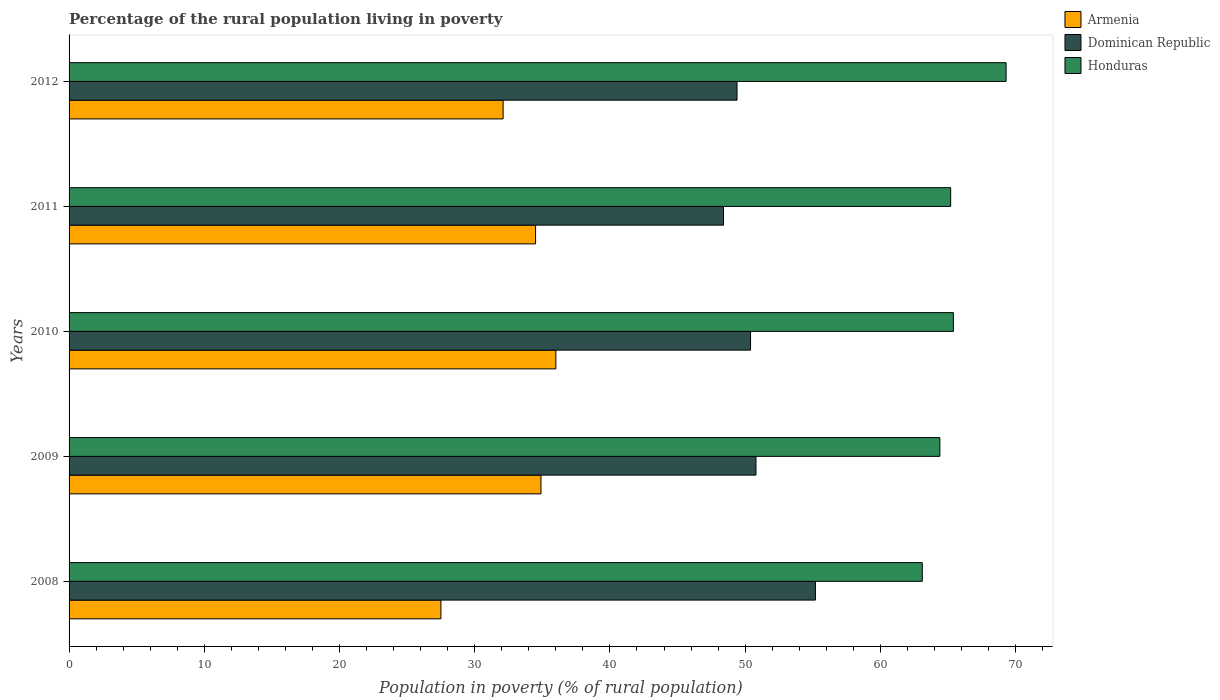How many different coloured bars are there?
Make the answer very short. 3. Are the number of bars on each tick of the Y-axis equal?
Give a very brief answer. Yes. How many bars are there on the 2nd tick from the top?
Provide a succinct answer. 3. What is the label of the 4th group of bars from the top?
Ensure brevity in your answer.  2009. In how many cases, is the number of bars for a given year not equal to the number of legend labels?
Give a very brief answer. 0. What is the percentage of the rural population living in poverty in Dominican Republic in 2008?
Your response must be concise. 55.2. In which year was the percentage of the rural population living in poverty in Armenia maximum?
Offer a terse response. 2010. In which year was the percentage of the rural population living in poverty in Honduras minimum?
Offer a very short reply. 2008. What is the total percentage of the rural population living in poverty in Dominican Republic in the graph?
Ensure brevity in your answer.  254.2. What is the difference between the percentage of the rural population living in poverty in Dominican Republic in 2011 and that in 2012?
Provide a short and direct response. -1. What is the difference between the percentage of the rural population living in poverty in Armenia in 2010 and the percentage of the rural population living in poverty in Dominican Republic in 2012?
Provide a succinct answer. -13.4. What is the average percentage of the rural population living in poverty in Dominican Republic per year?
Offer a very short reply. 50.84. In the year 2011, what is the difference between the percentage of the rural population living in poverty in Armenia and percentage of the rural population living in poverty in Honduras?
Provide a succinct answer. -30.7. What is the ratio of the percentage of the rural population living in poverty in Dominican Republic in 2010 to that in 2011?
Your answer should be very brief. 1.04. Is the percentage of the rural population living in poverty in Honduras in 2008 less than that in 2010?
Make the answer very short. Yes. What is the difference between the highest and the second highest percentage of the rural population living in poverty in Dominican Republic?
Give a very brief answer. 4.4. What is the difference between the highest and the lowest percentage of the rural population living in poverty in Honduras?
Your answer should be compact. 6.2. In how many years, is the percentage of the rural population living in poverty in Armenia greater than the average percentage of the rural population living in poverty in Armenia taken over all years?
Your response must be concise. 3. Is the sum of the percentage of the rural population living in poverty in Armenia in 2010 and 2012 greater than the maximum percentage of the rural population living in poverty in Dominican Republic across all years?
Offer a very short reply. Yes. What does the 3rd bar from the top in 2012 represents?
Keep it short and to the point. Armenia. What does the 1st bar from the bottom in 2009 represents?
Make the answer very short. Armenia. Is it the case that in every year, the sum of the percentage of the rural population living in poverty in Armenia and percentage of the rural population living in poverty in Honduras is greater than the percentage of the rural population living in poverty in Dominican Republic?
Provide a short and direct response. Yes. How many bars are there?
Provide a short and direct response. 15. How many years are there in the graph?
Your answer should be compact. 5. Are the values on the major ticks of X-axis written in scientific E-notation?
Your answer should be very brief. No. Does the graph contain any zero values?
Make the answer very short. No. Does the graph contain grids?
Ensure brevity in your answer.  No. How are the legend labels stacked?
Offer a terse response. Vertical. What is the title of the graph?
Your response must be concise. Percentage of the rural population living in poverty. What is the label or title of the X-axis?
Make the answer very short. Population in poverty (% of rural population). What is the Population in poverty (% of rural population) in Armenia in 2008?
Your answer should be compact. 27.5. What is the Population in poverty (% of rural population) in Dominican Republic in 2008?
Your answer should be very brief. 55.2. What is the Population in poverty (% of rural population) of Honduras in 2008?
Offer a very short reply. 63.1. What is the Population in poverty (% of rural population) in Armenia in 2009?
Provide a succinct answer. 34.9. What is the Population in poverty (% of rural population) in Dominican Republic in 2009?
Provide a short and direct response. 50.8. What is the Population in poverty (% of rural population) in Honduras in 2009?
Make the answer very short. 64.4. What is the Population in poverty (% of rural population) in Armenia in 2010?
Your response must be concise. 36. What is the Population in poverty (% of rural population) of Dominican Republic in 2010?
Keep it short and to the point. 50.4. What is the Population in poverty (% of rural population) of Honduras in 2010?
Ensure brevity in your answer.  65.4. What is the Population in poverty (% of rural population) of Armenia in 2011?
Offer a terse response. 34.5. What is the Population in poverty (% of rural population) of Dominican Republic in 2011?
Make the answer very short. 48.4. What is the Population in poverty (% of rural population) in Honduras in 2011?
Provide a succinct answer. 65.2. What is the Population in poverty (% of rural population) in Armenia in 2012?
Ensure brevity in your answer.  32.1. What is the Population in poverty (% of rural population) of Dominican Republic in 2012?
Make the answer very short. 49.4. What is the Population in poverty (% of rural population) of Honduras in 2012?
Your answer should be compact. 69.3. Across all years, what is the maximum Population in poverty (% of rural population) in Armenia?
Offer a terse response. 36. Across all years, what is the maximum Population in poverty (% of rural population) in Dominican Republic?
Keep it short and to the point. 55.2. Across all years, what is the maximum Population in poverty (% of rural population) in Honduras?
Keep it short and to the point. 69.3. Across all years, what is the minimum Population in poverty (% of rural population) of Dominican Republic?
Provide a short and direct response. 48.4. Across all years, what is the minimum Population in poverty (% of rural population) of Honduras?
Offer a terse response. 63.1. What is the total Population in poverty (% of rural population) of Armenia in the graph?
Your answer should be compact. 165. What is the total Population in poverty (% of rural population) in Dominican Republic in the graph?
Keep it short and to the point. 254.2. What is the total Population in poverty (% of rural population) of Honduras in the graph?
Give a very brief answer. 327.4. What is the difference between the Population in poverty (% of rural population) in Dominican Republic in 2008 and that in 2009?
Ensure brevity in your answer.  4.4. What is the difference between the Population in poverty (% of rural population) in Armenia in 2008 and that in 2010?
Ensure brevity in your answer.  -8.5. What is the difference between the Population in poverty (% of rural population) of Dominican Republic in 2008 and that in 2010?
Keep it short and to the point. 4.8. What is the difference between the Population in poverty (% of rural population) in Honduras in 2008 and that in 2010?
Keep it short and to the point. -2.3. What is the difference between the Population in poverty (% of rural population) in Armenia in 2008 and that in 2011?
Your answer should be compact. -7. What is the difference between the Population in poverty (% of rural population) of Honduras in 2008 and that in 2011?
Ensure brevity in your answer.  -2.1. What is the difference between the Population in poverty (% of rural population) in Armenia in 2008 and that in 2012?
Offer a very short reply. -4.6. What is the difference between the Population in poverty (% of rural population) in Honduras in 2008 and that in 2012?
Give a very brief answer. -6.2. What is the difference between the Population in poverty (% of rural population) of Dominican Republic in 2009 and that in 2010?
Make the answer very short. 0.4. What is the difference between the Population in poverty (% of rural population) in Honduras in 2009 and that in 2010?
Offer a very short reply. -1. What is the difference between the Population in poverty (% of rural population) of Armenia in 2009 and that in 2011?
Your answer should be very brief. 0.4. What is the difference between the Population in poverty (% of rural population) in Honduras in 2009 and that in 2011?
Your answer should be very brief. -0.8. What is the difference between the Population in poverty (% of rural population) in Armenia in 2009 and that in 2012?
Offer a terse response. 2.8. What is the difference between the Population in poverty (% of rural population) in Dominican Republic in 2009 and that in 2012?
Ensure brevity in your answer.  1.4. What is the difference between the Population in poverty (% of rural population) of Honduras in 2009 and that in 2012?
Make the answer very short. -4.9. What is the difference between the Population in poverty (% of rural population) in Armenia in 2010 and that in 2012?
Your answer should be compact. 3.9. What is the difference between the Population in poverty (% of rural population) of Honduras in 2010 and that in 2012?
Provide a short and direct response. -3.9. What is the difference between the Population in poverty (% of rural population) of Armenia in 2008 and the Population in poverty (% of rural population) of Dominican Republic in 2009?
Your answer should be very brief. -23.3. What is the difference between the Population in poverty (% of rural population) in Armenia in 2008 and the Population in poverty (% of rural population) in Honduras in 2009?
Offer a very short reply. -36.9. What is the difference between the Population in poverty (% of rural population) in Dominican Republic in 2008 and the Population in poverty (% of rural population) in Honduras in 2009?
Offer a terse response. -9.2. What is the difference between the Population in poverty (% of rural population) in Armenia in 2008 and the Population in poverty (% of rural population) in Dominican Republic in 2010?
Ensure brevity in your answer.  -22.9. What is the difference between the Population in poverty (% of rural population) of Armenia in 2008 and the Population in poverty (% of rural population) of Honduras in 2010?
Offer a terse response. -37.9. What is the difference between the Population in poverty (% of rural population) of Dominican Republic in 2008 and the Population in poverty (% of rural population) of Honduras in 2010?
Make the answer very short. -10.2. What is the difference between the Population in poverty (% of rural population) in Armenia in 2008 and the Population in poverty (% of rural population) in Dominican Republic in 2011?
Give a very brief answer. -20.9. What is the difference between the Population in poverty (% of rural population) in Armenia in 2008 and the Population in poverty (% of rural population) in Honduras in 2011?
Offer a very short reply. -37.7. What is the difference between the Population in poverty (% of rural population) of Dominican Republic in 2008 and the Population in poverty (% of rural population) of Honduras in 2011?
Keep it short and to the point. -10. What is the difference between the Population in poverty (% of rural population) of Armenia in 2008 and the Population in poverty (% of rural population) of Dominican Republic in 2012?
Provide a succinct answer. -21.9. What is the difference between the Population in poverty (% of rural population) in Armenia in 2008 and the Population in poverty (% of rural population) in Honduras in 2012?
Ensure brevity in your answer.  -41.8. What is the difference between the Population in poverty (% of rural population) in Dominican Republic in 2008 and the Population in poverty (% of rural population) in Honduras in 2012?
Ensure brevity in your answer.  -14.1. What is the difference between the Population in poverty (% of rural population) of Armenia in 2009 and the Population in poverty (% of rural population) of Dominican Republic in 2010?
Provide a short and direct response. -15.5. What is the difference between the Population in poverty (% of rural population) of Armenia in 2009 and the Population in poverty (% of rural population) of Honduras in 2010?
Offer a terse response. -30.5. What is the difference between the Population in poverty (% of rural population) in Dominican Republic in 2009 and the Population in poverty (% of rural population) in Honduras in 2010?
Your answer should be very brief. -14.6. What is the difference between the Population in poverty (% of rural population) in Armenia in 2009 and the Population in poverty (% of rural population) in Honduras in 2011?
Ensure brevity in your answer.  -30.3. What is the difference between the Population in poverty (% of rural population) in Dominican Republic in 2009 and the Population in poverty (% of rural population) in Honduras in 2011?
Offer a very short reply. -14.4. What is the difference between the Population in poverty (% of rural population) of Armenia in 2009 and the Population in poverty (% of rural population) of Dominican Republic in 2012?
Provide a succinct answer. -14.5. What is the difference between the Population in poverty (% of rural population) in Armenia in 2009 and the Population in poverty (% of rural population) in Honduras in 2012?
Your answer should be compact. -34.4. What is the difference between the Population in poverty (% of rural population) in Dominican Republic in 2009 and the Population in poverty (% of rural population) in Honduras in 2012?
Ensure brevity in your answer.  -18.5. What is the difference between the Population in poverty (% of rural population) of Armenia in 2010 and the Population in poverty (% of rural population) of Honduras in 2011?
Ensure brevity in your answer.  -29.2. What is the difference between the Population in poverty (% of rural population) of Dominican Republic in 2010 and the Population in poverty (% of rural population) of Honduras in 2011?
Your answer should be compact. -14.8. What is the difference between the Population in poverty (% of rural population) in Armenia in 2010 and the Population in poverty (% of rural population) in Dominican Republic in 2012?
Make the answer very short. -13.4. What is the difference between the Population in poverty (% of rural population) in Armenia in 2010 and the Population in poverty (% of rural population) in Honduras in 2012?
Your response must be concise. -33.3. What is the difference between the Population in poverty (% of rural population) of Dominican Republic in 2010 and the Population in poverty (% of rural population) of Honduras in 2012?
Keep it short and to the point. -18.9. What is the difference between the Population in poverty (% of rural population) in Armenia in 2011 and the Population in poverty (% of rural population) in Dominican Republic in 2012?
Make the answer very short. -14.9. What is the difference between the Population in poverty (% of rural population) of Armenia in 2011 and the Population in poverty (% of rural population) of Honduras in 2012?
Your answer should be very brief. -34.8. What is the difference between the Population in poverty (% of rural population) in Dominican Republic in 2011 and the Population in poverty (% of rural population) in Honduras in 2012?
Your answer should be compact. -20.9. What is the average Population in poverty (% of rural population) in Dominican Republic per year?
Make the answer very short. 50.84. What is the average Population in poverty (% of rural population) in Honduras per year?
Ensure brevity in your answer.  65.48. In the year 2008, what is the difference between the Population in poverty (% of rural population) in Armenia and Population in poverty (% of rural population) in Dominican Republic?
Offer a terse response. -27.7. In the year 2008, what is the difference between the Population in poverty (% of rural population) in Armenia and Population in poverty (% of rural population) in Honduras?
Make the answer very short. -35.6. In the year 2009, what is the difference between the Population in poverty (% of rural population) of Armenia and Population in poverty (% of rural population) of Dominican Republic?
Offer a very short reply. -15.9. In the year 2009, what is the difference between the Population in poverty (% of rural population) of Armenia and Population in poverty (% of rural population) of Honduras?
Give a very brief answer. -29.5. In the year 2010, what is the difference between the Population in poverty (% of rural population) of Armenia and Population in poverty (% of rural population) of Dominican Republic?
Your response must be concise. -14.4. In the year 2010, what is the difference between the Population in poverty (% of rural population) of Armenia and Population in poverty (% of rural population) of Honduras?
Your answer should be compact. -29.4. In the year 2010, what is the difference between the Population in poverty (% of rural population) in Dominican Republic and Population in poverty (% of rural population) in Honduras?
Your answer should be compact. -15. In the year 2011, what is the difference between the Population in poverty (% of rural population) in Armenia and Population in poverty (% of rural population) in Dominican Republic?
Make the answer very short. -13.9. In the year 2011, what is the difference between the Population in poverty (% of rural population) of Armenia and Population in poverty (% of rural population) of Honduras?
Ensure brevity in your answer.  -30.7. In the year 2011, what is the difference between the Population in poverty (% of rural population) of Dominican Republic and Population in poverty (% of rural population) of Honduras?
Offer a very short reply. -16.8. In the year 2012, what is the difference between the Population in poverty (% of rural population) of Armenia and Population in poverty (% of rural population) of Dominican Republic?
Make the answer very short. -17.3. In the year 2012, what is the difference between the Population in poverty (% of rural population) of Armenia and Population in poverty (% of rural population) of Honduras?
Give a very brief answer. -37.2. In the year 2012, what is the difference between the Population in poverty (% of rural population) in Dominican Republic and Population in poverty (% of rural population) in Honduras?
Offer a very short reply. -19.9. What is the ratio of the Population in poverty (% of rural population) of Armenia in 2008 to that in 2009?
Provide a short and direct response. 0.79. What is the ratio of the Population in poverty (% of rural population) of Dominican Republic in 2008 to that in 2009?
Provide a short and direct response. 1.09. What is the ratio of the Population in poverty (% of rural population) of Honduras in 2008 to that in 2009?
Offer a terse response. 0.98. What is the ratio of the Population in poverty (% of rural population) in Armenia in 2008 to that in 2010?
Give a very brief answer. 0.76. What is the ratio of the Population in poverty (% of rural population) of Dominican Republic in 2008 to that in 2010?
Provide a succinct answer. 1.1. What is the ratio of the Population in poverty (% of rural population) of Honduras in 2008 to that in 2010?
Provide a succinct answer. 0.96. What is the ratio of the Population in poverty (% of rural population) of Armenia in 2008 to that in 2011?
Offer a terse response. 0.8. What is the ratio of the Population in poverty (% of rural population) in Dominican Republic in 2008 to that in 2011?
Offer a terse response. 1.14. What is the ratio of the Population in poverty (% of rural population) of Honduras in 2008 to that in 2011?
Your answer should be very brief. 0.97. What is the ratio of the Population in poverty (% of rural population) of Armenia in 2008 to that in 2012?
Your response must be concise. 0.86. What is the ratio of the Population in poverty (% of rural population) in Dominican Republic in 2008 to that in 2012?
Give a very brief answer. 1.12. What is the ratio of the Population in poverty (% of rural population) of Honduras in 2008 to that in 2012?
Ensure brevity in your answer.  0.91. What is the ratio of the Population in poverty (% of rural population) in Armenia in 2009 to that in 2010?
Your answer should be very brief. 0.97. What is the ratio of the Population in poverty (% of rural population) in Dominican Republic in 2009 to that in 2010?
Ensure brevity in your answer.  1.01. What is the ratio of the Population in poverty (% of rural population) in Honduras in 2009 to that in 2010?
Make the answer very short. 0.98. What is the ratio of the Population in poverty (% of rural population) in Armenia in 2009 to that in 2011?
Keep it short and to the point. 1.01. What is the ratio of the Population in poverty (% of rural population) in Dominican Republic in 2009 to that in 2011?
Give a very brief answer. 1.05. What is the ratio of the Population in poverty (% of rural population) of Armenia in 2009 to that in 2012?
Ensure brevity in your answer.  1.09. What is the ratio of the Population in poverty (% of rural population) of Dominican Republic in 2009 to that in 2012?
Provide a short and direct response. 1.03. What is the ratio of the Population in poverty (% of rural population) of Honduras in 2009 to that in 2012?
Provide a succinct answer. 0.93. What is the ratio of the Population in poverty (% of rural population) in Armenia in 2010 to that in 2011?
Offer a very short reply. 1.04. What is the ratio of the Population in poverty (% of rural population) in Dominican Republic in 2010 to that in 2011?
Keep it short and to the point. 1.04. What is the ratio of the Population in poverty (% of rural population) in Armenia in 2010 to that in 2012?
Keep it short and to the point. 1.12. What is the ratio of the Population in poverty (% of rural population) in Dominican Republic in 2010 to that in 2012?
Ensure brevity in your answer.  1.02. What is the ratio of the Population in poverty (% of rural population) in Honduras in 2010 to that in 2012?
Your response must be concise. 0.94. What is the ratio of the Population in poverty (% of rural population) of Armenia in 2011 to that in 2012?
Offer a very short reply. 1.07. What is the ratio of the Population in poverty (% of rural population) of Dominican Republic in 2011 to that in 2012?
Keep it short and to the point. 0.98. What is the ratio of the Population in poverty (% of rural population) in Honduras in 2011 to that in 2012?
Make the answer very short. 0.94. What is the difference between the highest and the second highest Population in poverty (% of rural population) of Armenia?
Ensure brevity in your answer.  1.1. What is the difference between the highest and the lowest Population in poverty (% of rural population) in Armenia?
Keep it short and to the point. 8.5. What is the difference between the highest and the lowest Population in poverty (% of rural population) in Dominican Republic?
Give a very brief answer. 6.8. 